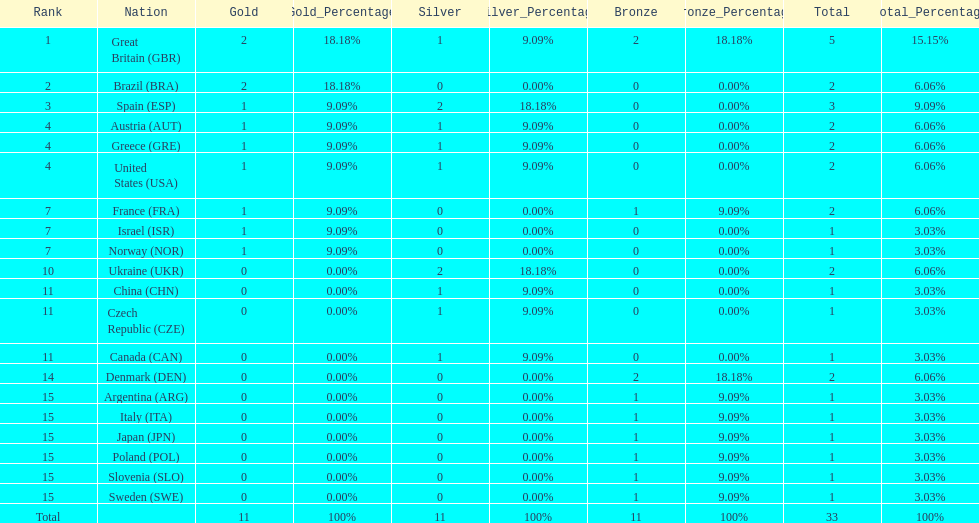Write the full table. {'header': ['Rank', 'Nation', 'Gold', 'Gold_Percentage', 'Silver', 'Silver_Percentage', 'Bronze', 'Bronze_Percentage', 'Total', 'Total_Percentage'], 'rows': [['1', 'Great Britain\xa0(GBR)', '2', '18.18%', '1', '9.09%', '2', '18.18%', '5', '15.15%'], ['2', 'Brazil\xa0(BRA)', '2', '18.18%', '0', '0.00%', '0', '0.00%', '2', '6.06%'], ['3', 'Spain\xa0(ESP)', '1', '9.09%', '2', '18.18%', '0', '0.00%', '3', '9.09%'], ['4', 'Austria\xa0(AUT)', '1', '9.09%', '1', '9.09%', '0', '0.00%', '2', '6.06%'], ['4', 'Greece\xa0(GRE)', '1', '9.09%', '1', '9.09%', '0', '0.00%', '2', '6.06%'], ['4', 'United States\xa0(USA)', '1', '9.09%', '1', '9.09%', '0', '0.00%', '2', '6.06%'], ['7', 'France\xa0(FRA)', '1', '9.09%', '0', '0.00%', '1', '9.09%', '2', '6.06%'], ['7', 'Israel\xa0(ISR)', '1', '9.09%', '0', '0.00%', '0', '0.00%', '1', '3.03%'], ['7', 'Norway\xa0(NOR)', '1', '9.09%', '0', '0.00%', '0', '0.00%', '1', '3.03%'], ['10', 'Ukraine\xa0(UKR)', '0', '0.00%', '2', '18.18%', '0', '0.00%', '2', '6.06%'], ['11', 'China\xa0(CHN)', '0', '0.00%', '1', '9.09%', '0', '0.00%', '1', '3.03%'], ['11', 'Czech Republic\xa0(CZE)', '0', '0.00%', '1', '9.09%', '0', '0.00%', '1', '3.03%'], ['11', 'Canada\xa0(CAN)', '0', '0.00%', '1', '9.09%', '0', '0.00%', '1', '3.03%'], ['14', 'Denmark\xa0(DEN)', '0', '0.00%', '0', '0.00%', '2', '18.18%', '2', '6.06%'], ['15', 'Argentina\xa0(ARG)', '0', '0.00%', '0', '0.00%', '1', '9.09%', '1', '3.03%'], ['15', 'Italy\xa0(ITA)', '0', '0.00%', '0', '0.00%', '1', '9.09%', '1', '3.03%'], ['15', 'Japan\xa0(JPN)', '0', '0.00%', '0', '0.00%', '1', '9.09%', '1', '3.03%'], ['15', 'Poland\xa0(POL)', '0', '0.00%', '0', '0.00%', '1', '9.09%', '1', '3.03%'], ['15', 'Slovenia\xa0(SLO)', '0', '0.00%', '0', '0.00%', '1', '9.09%', '1', '3.03%'], ['15', 'Sweden\xa0(SWE)', '0', '0.00%', '0', '0.00%', '1', '9.09%', '1', '3.03%'], ['Total', '', '11', '100%', '11', '100%', '11', '100%', '33', '100%']]} Who won more gold medals than spain? Great Britain (GBR), Brazil (BRA). 